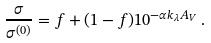Convert formula to latex. <formula><loc_0><loc_0><loc_500><loc_500>\frac { \sigma } { \sigma ^ { ( 0 ) } } = f + ( 1 - f ) 1 0 ^ { - \alpha k _ { \lambda } A _ { V } } \, .</formula> 